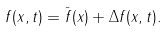<formula> <loc_0><loc_0><loc_500><loc_500>f ( x , t ) = \bar { f } ( x ) + \Delta f ( x , t ) .</formula> 